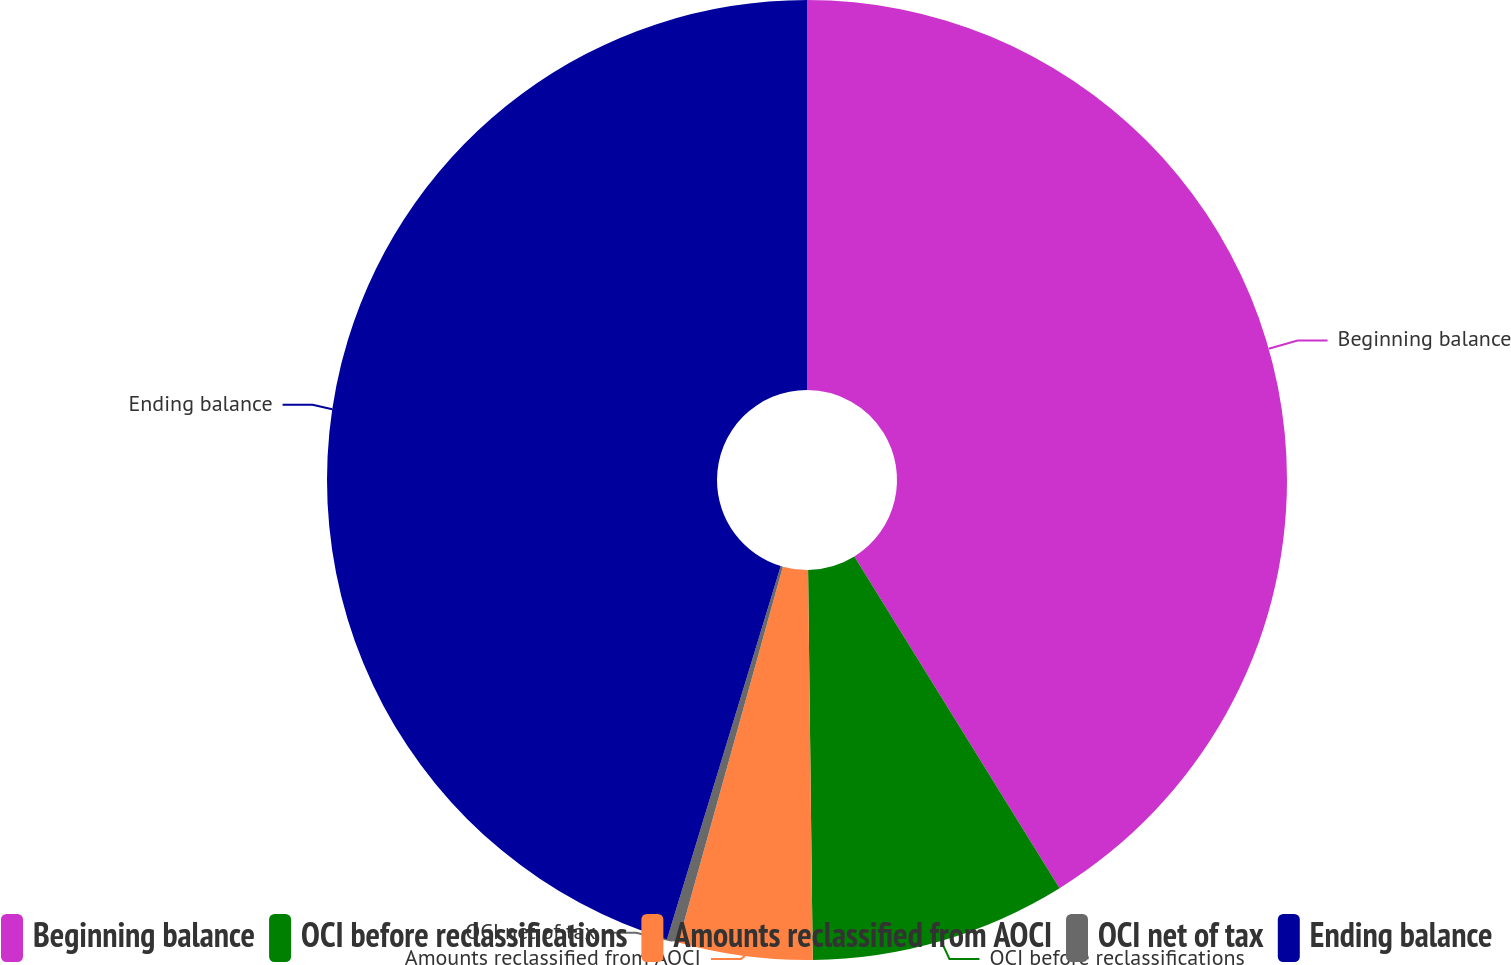<chart> <loc_0><loc_0><loc_500><loc_500><pie_chart><fcel>Beginning balance<fcel>OCI before reclassifications<fcel>Amounts reclassified from AOCI<fcel>OCI net of tax<fcel>Ending balance<nl><fcel>41.18%<fcel>8.63%<fcel>4.51%<fcel>0.39%<fcel>45.29%<nl></chart> 